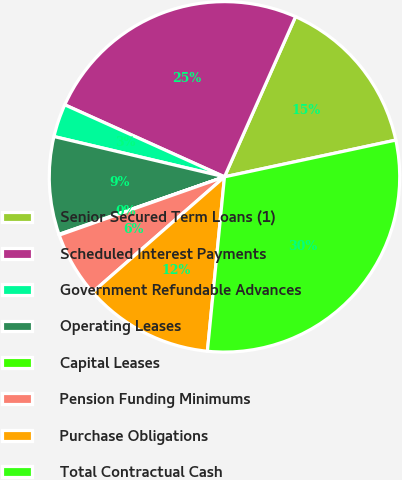Convert chart. <chart><loc_0><loc_0><loc_500><loc_500><pie_chart><fcel>Senior Secured Term Loans (1)<fcel>Scheduled Interest Payments<fcel>Government Refundable Advances<fcel>Operating Leases<fcel>Capital Leases<fcel>Pension Funding Minimums<fcel>Purchase Obligations<fcel>Total Contractual Cash<nl><fcel>14.99%<fcel>24.9%<fcel>3.05%<fcel>9.02%<fcel>0.07%<fcel>6.04%<fcel>12.01%<fcel>29.92%<nl></chart> 